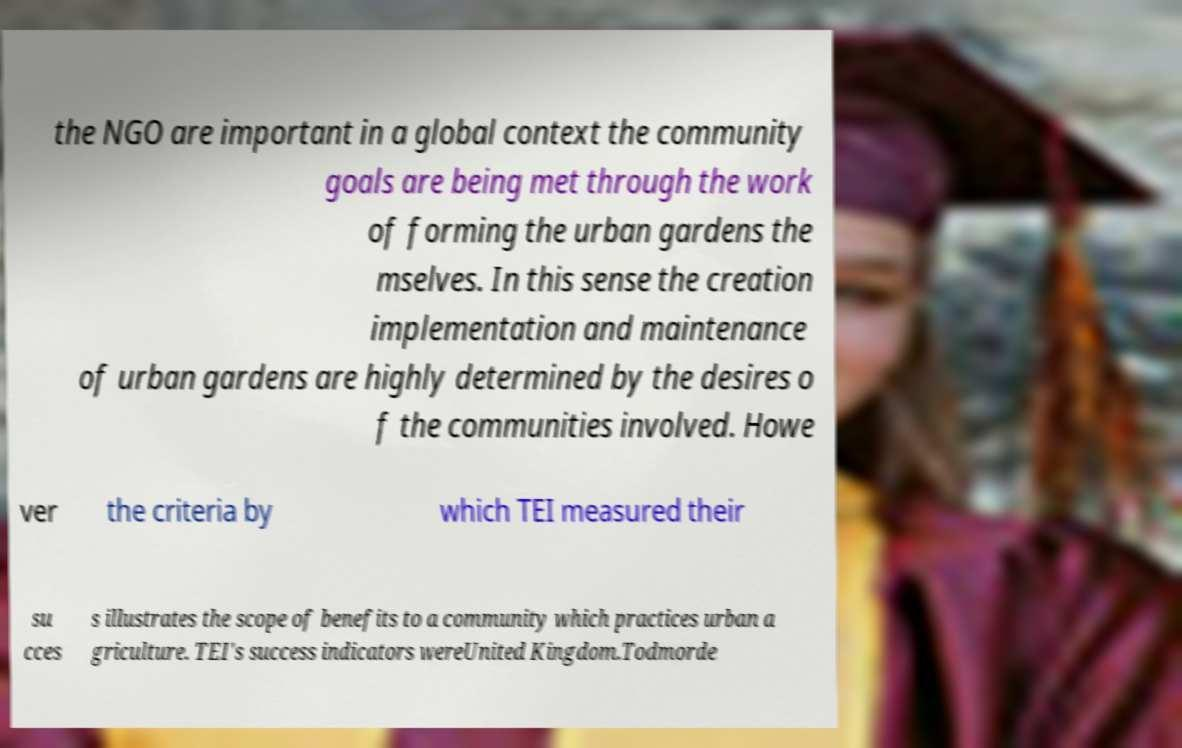Can you accurately transcribe the text from the provided image for me? the NGO are important in a global context the community goals are being met through the work of forming the urban gardens the mselves. In this sense the creation implementation and maintenance of urban gardens are highly determined by the desires o f the communities involved. Howe ver the criteria by which TEI measured their su cces s illustrates the scope of benefits to a community which practices urban a griculture. TEI's success indicators wereUnited Kingdom.Todmorde 